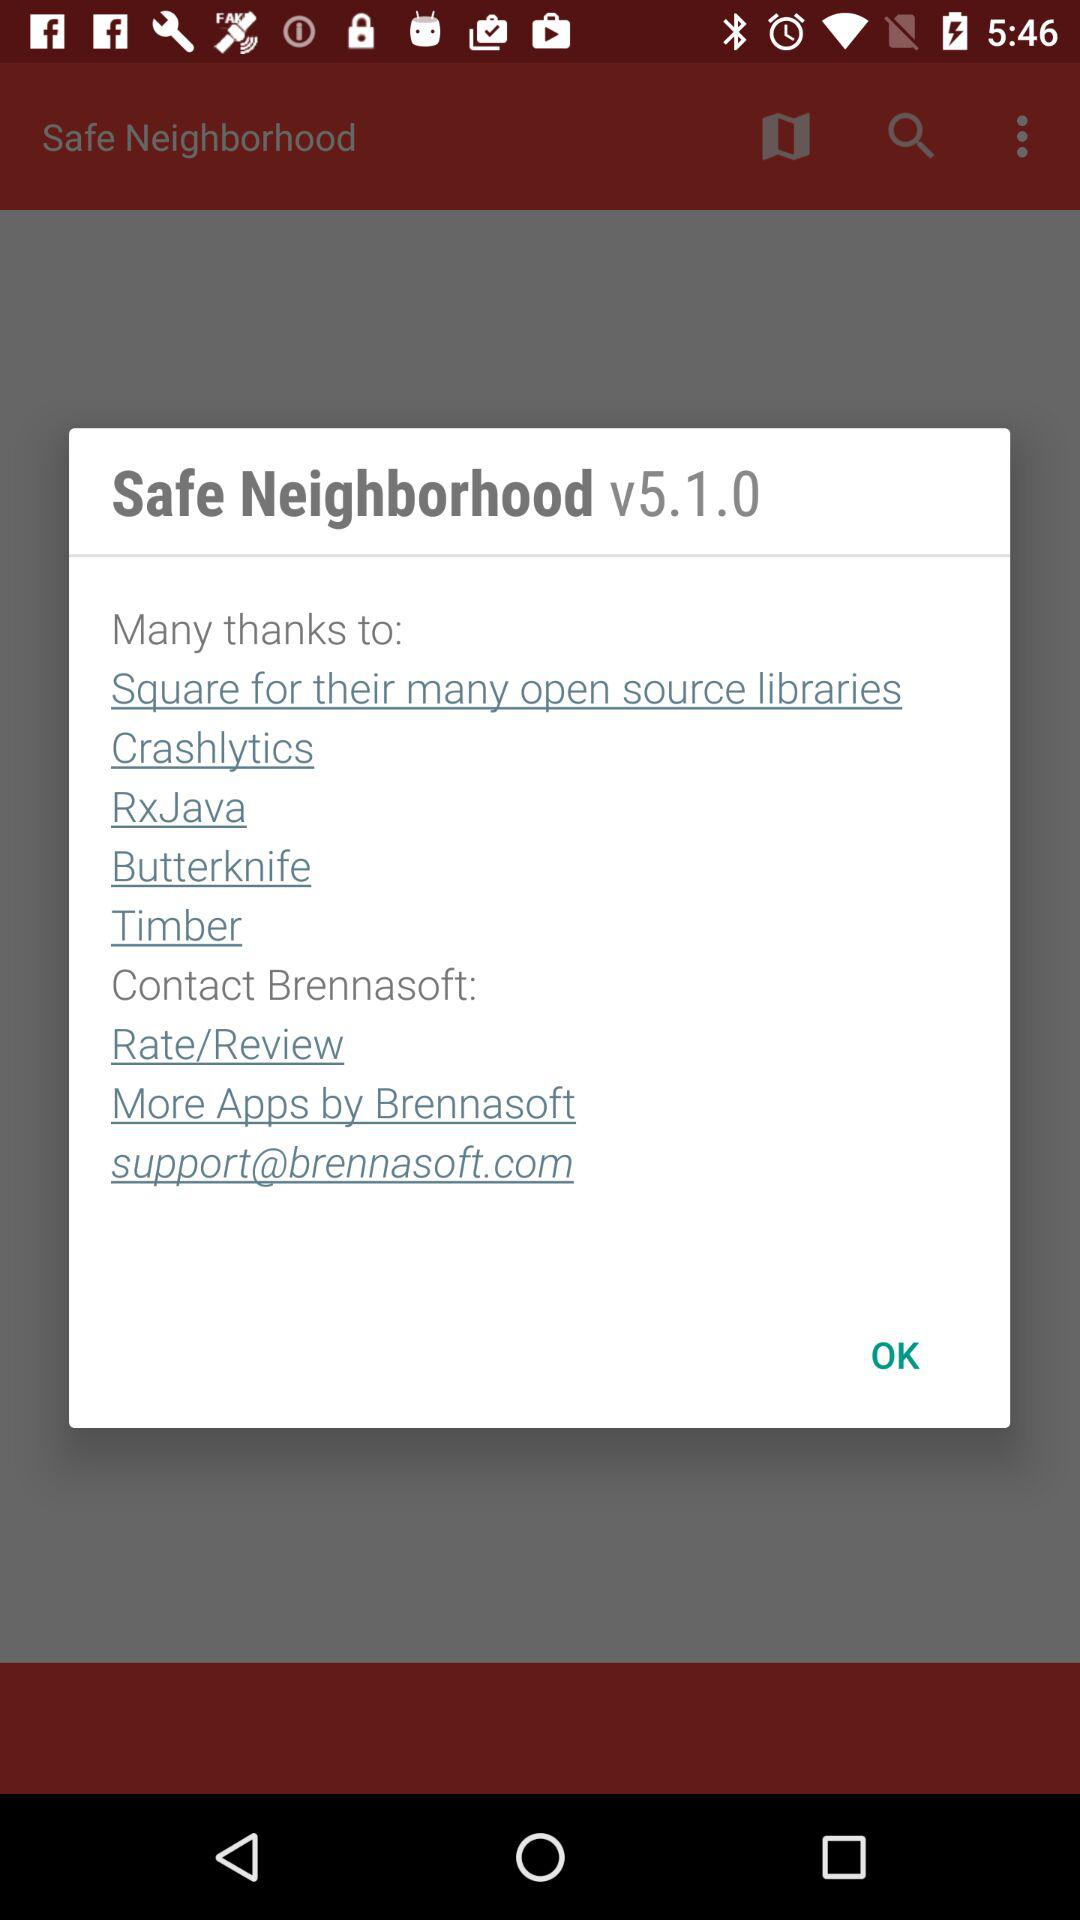What is the name of the application? The name of the application is "Safe Neighborhood". 